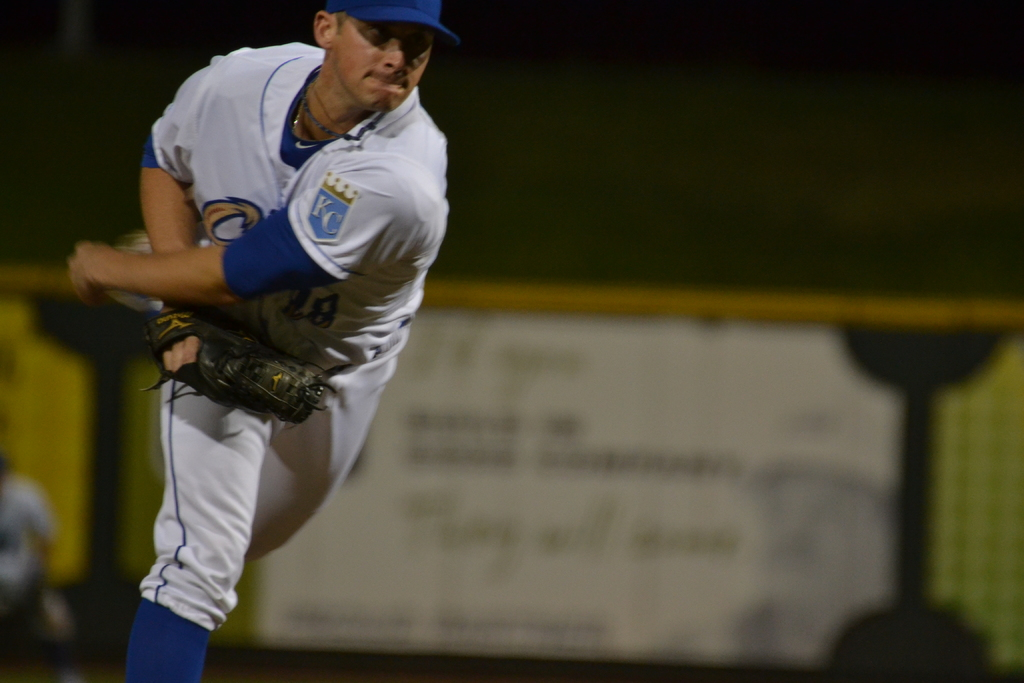Describe the environment shown in the image. The image captures a nighttime baseball game, evident from the illuminated field and the blurred background spotlighting mainly on the pitcher. 